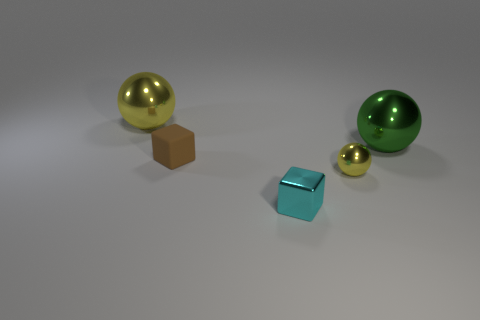Subtract all big yellow balls. How many balls are left? 2 Subtract all cyan blocks. How many yellow balls are left? 2 Add 2 big cyan metallic blocks. How many objects exist? 7 Subtract all blue spheres. Subtract all yellow cubes. How many spheres are left? 3 Subtract 0 cyan cylinders. How many objects are left? 5 Subtract all blocks. How many objects are left? 3 Subtract all small brown cubes. Subtract all tiny cyan metal things. How many objects are left? 3 Add 4 large green shiny spheres. How many large green shiny spheres are left? 5 Add 4 small red rubber cubes. How many small red rubber cubes exist? 4 